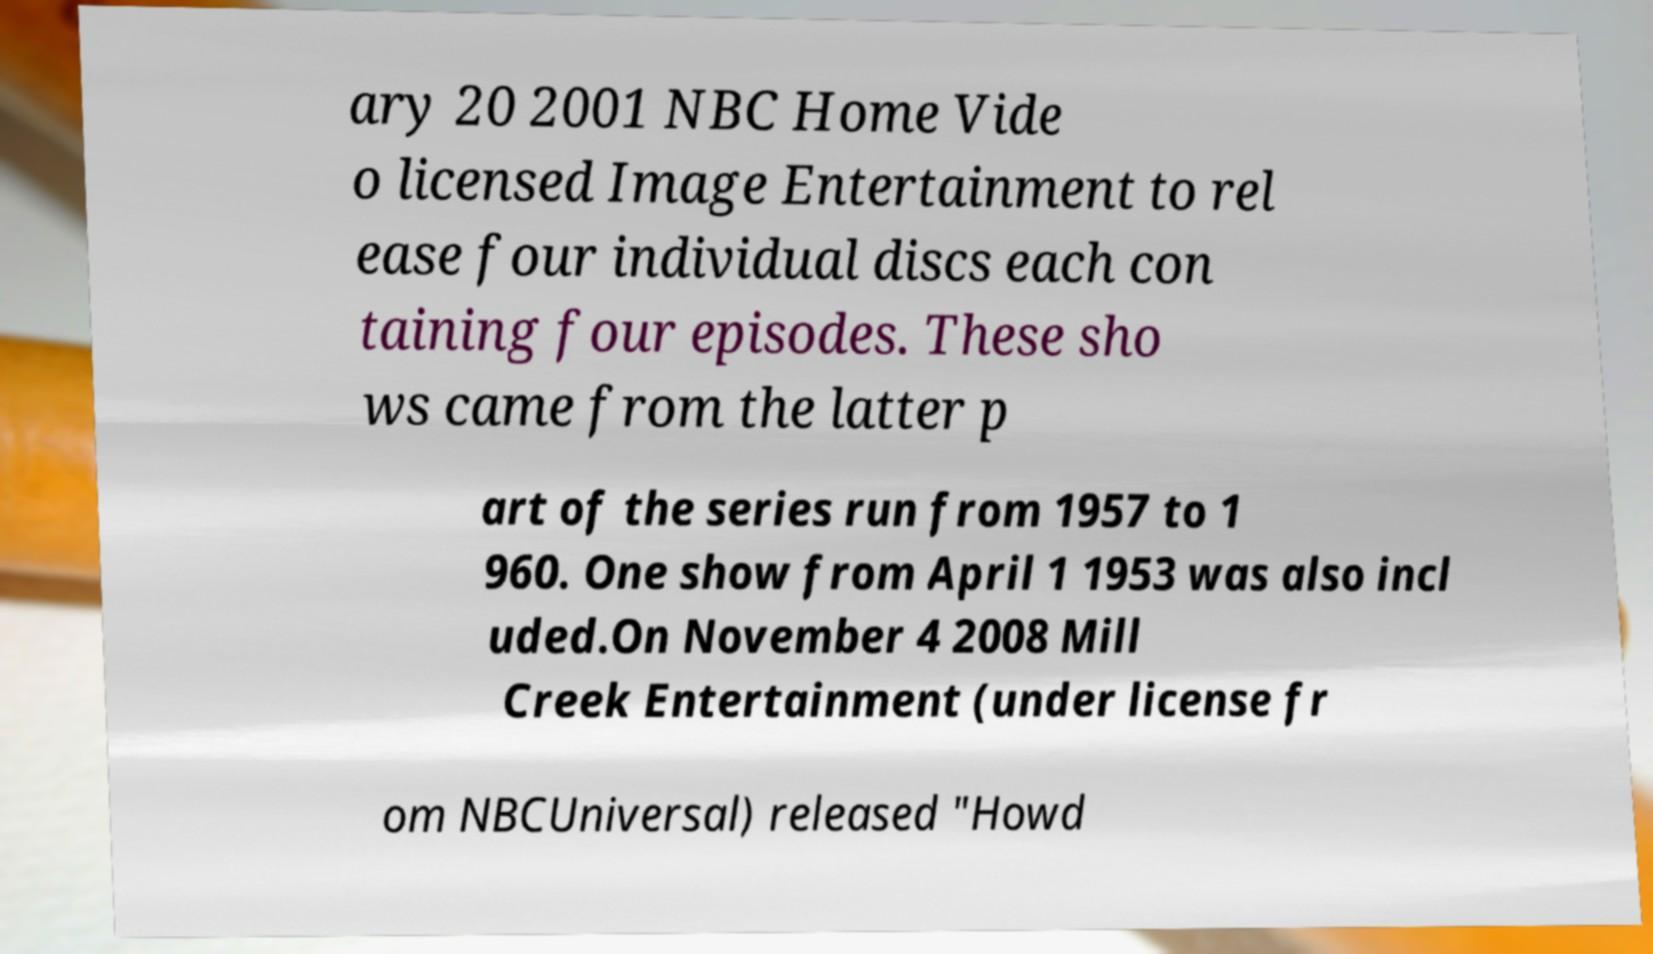Can you read and provide the text displayed in the image?This photo seems to have some interesting text. Can you extract and type it out for me? ary 20 2001 NBC Home Vide o licensed Image Entertainment to rel ease four individual discs each con taining four episodes. These sho ws came from the latter p art of the series run from 1957 to 1 960. One show from April 1 1953 was also incl uded.On November 4 2008 Mill Creek Entertainment (under license fr om NBCUniversal) released "Howd 